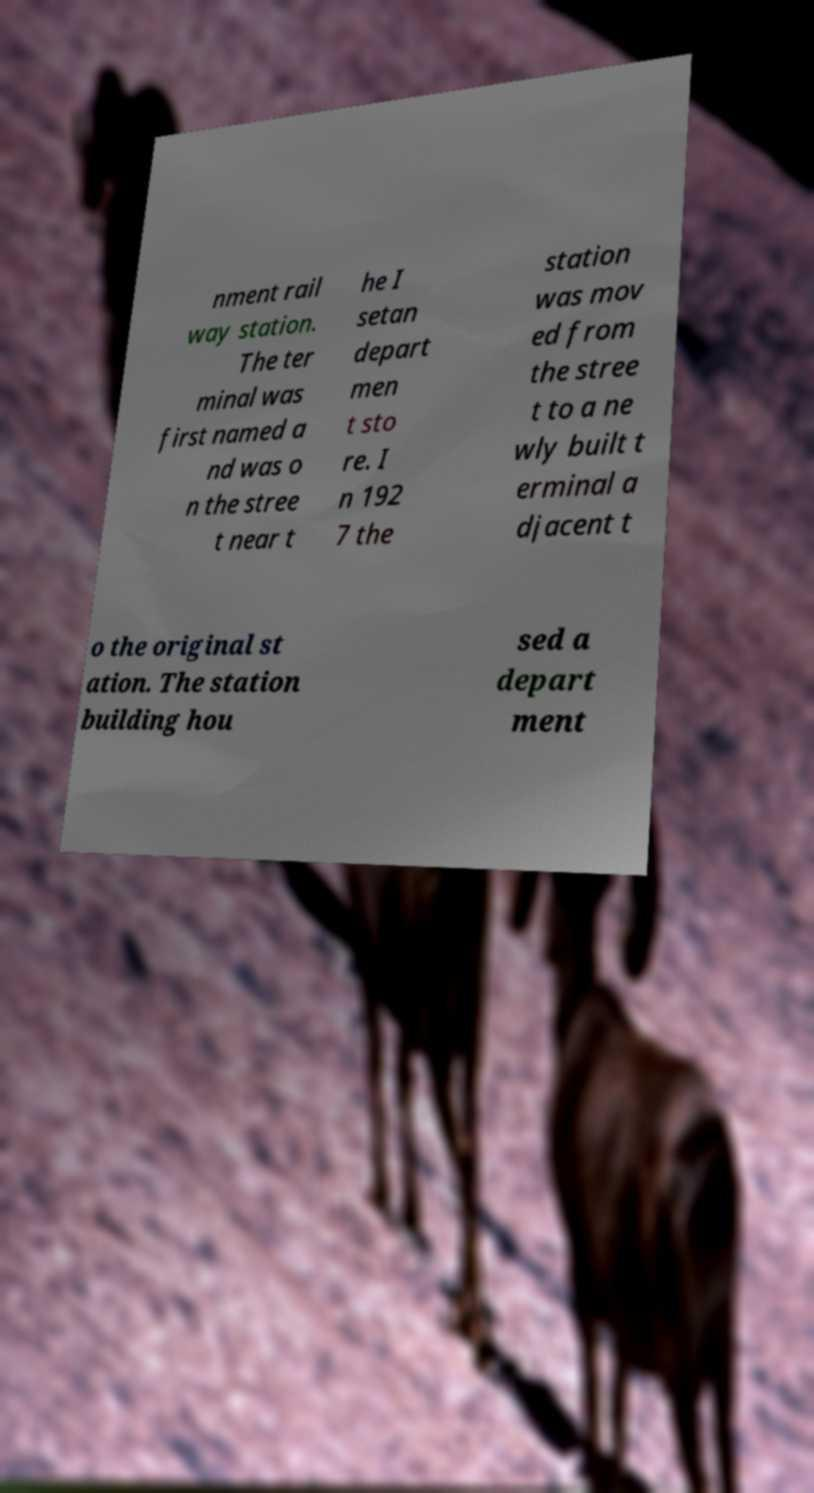Please read and relay the text visible in this image. What does it say? nment rail way station. The ter minal was first named a nd was o n the stree t near t he I setan depart men t sto re. I n 192 7 the station was mov ed from the stree t to a ne wly built t erminal a djacent t o the original st ation. The station building hou sed a depart ment 